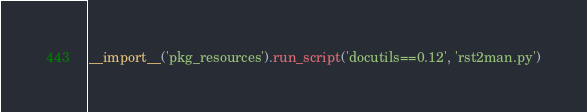<code> <loc_0><loc_0><loc_500><loc_500><_Python_>__import__('pkg_resources').run_script('docutils==0.12', 'rst2man.py')
</code> 